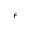<formula> <loc_0><loc_0><loc_500><loc_500>\epsilon</formula> 